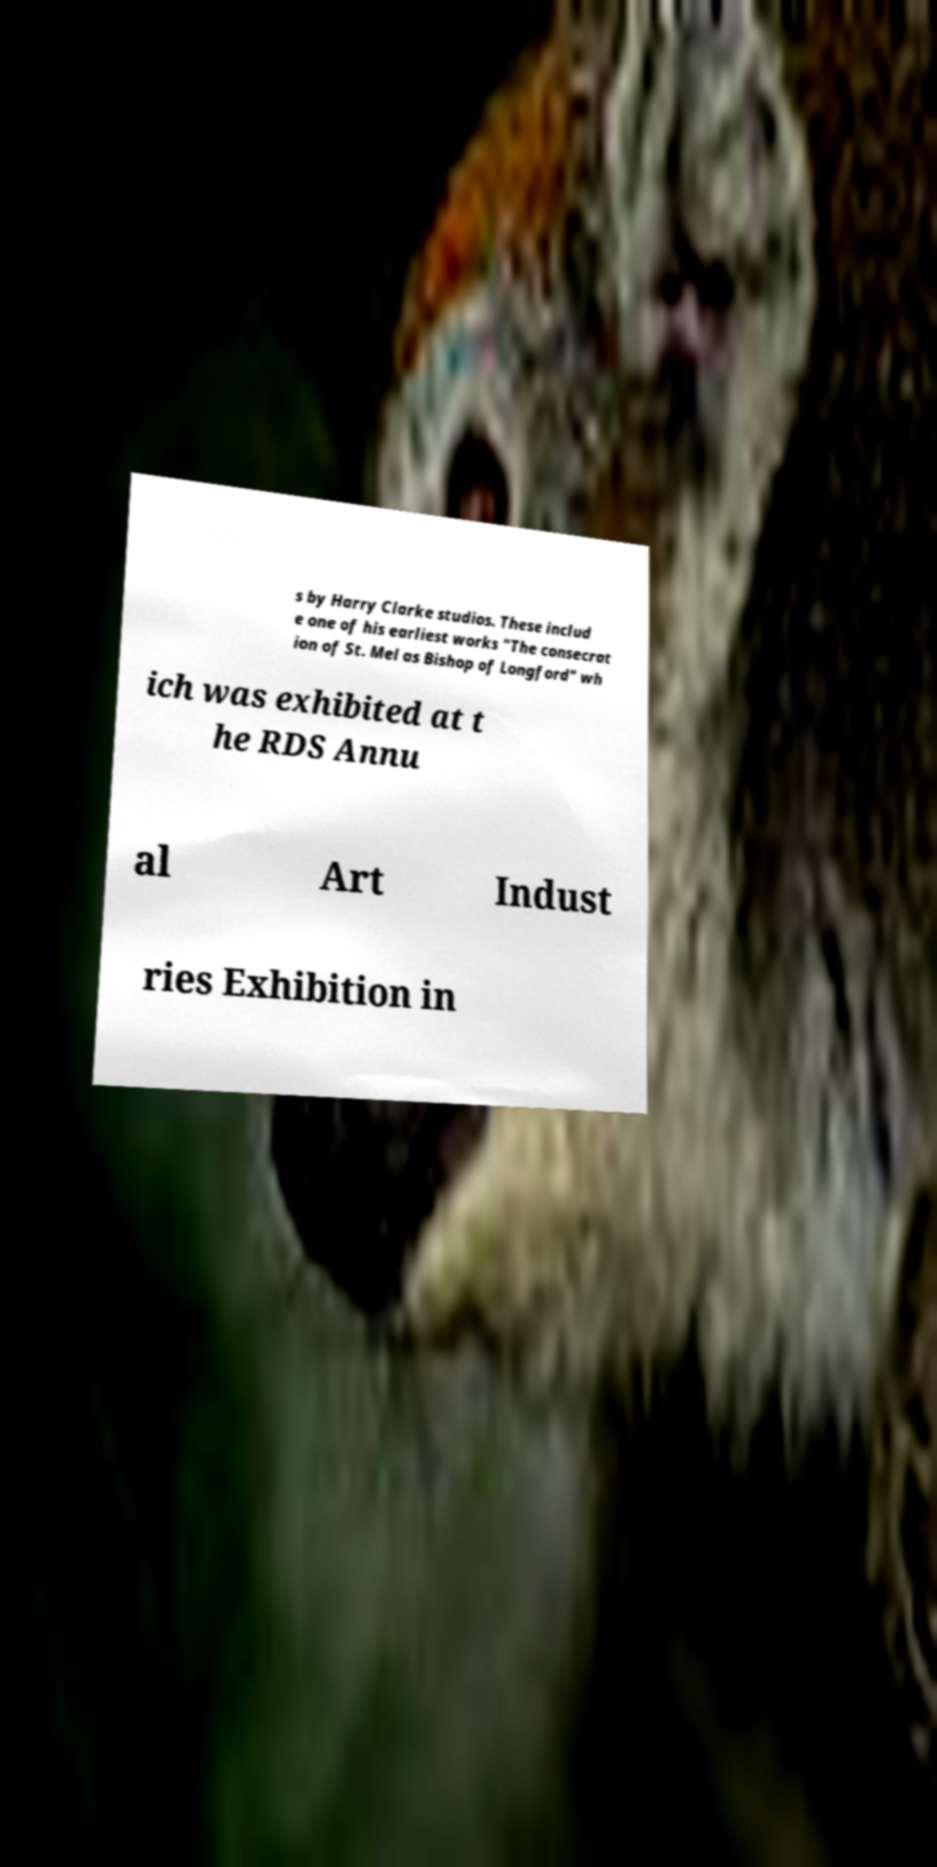Can you read and provide the text displayed in the image?This photo seems to have some interesting text. Can you extract and type it out for me? s by Harry Clarke studios. These includ e one of his earliest works "The consecrat ion of St. Mel as Bishop of Longford" wh ich was exhibited at t he RDS Annu al Art Indust ries Exhibition in 